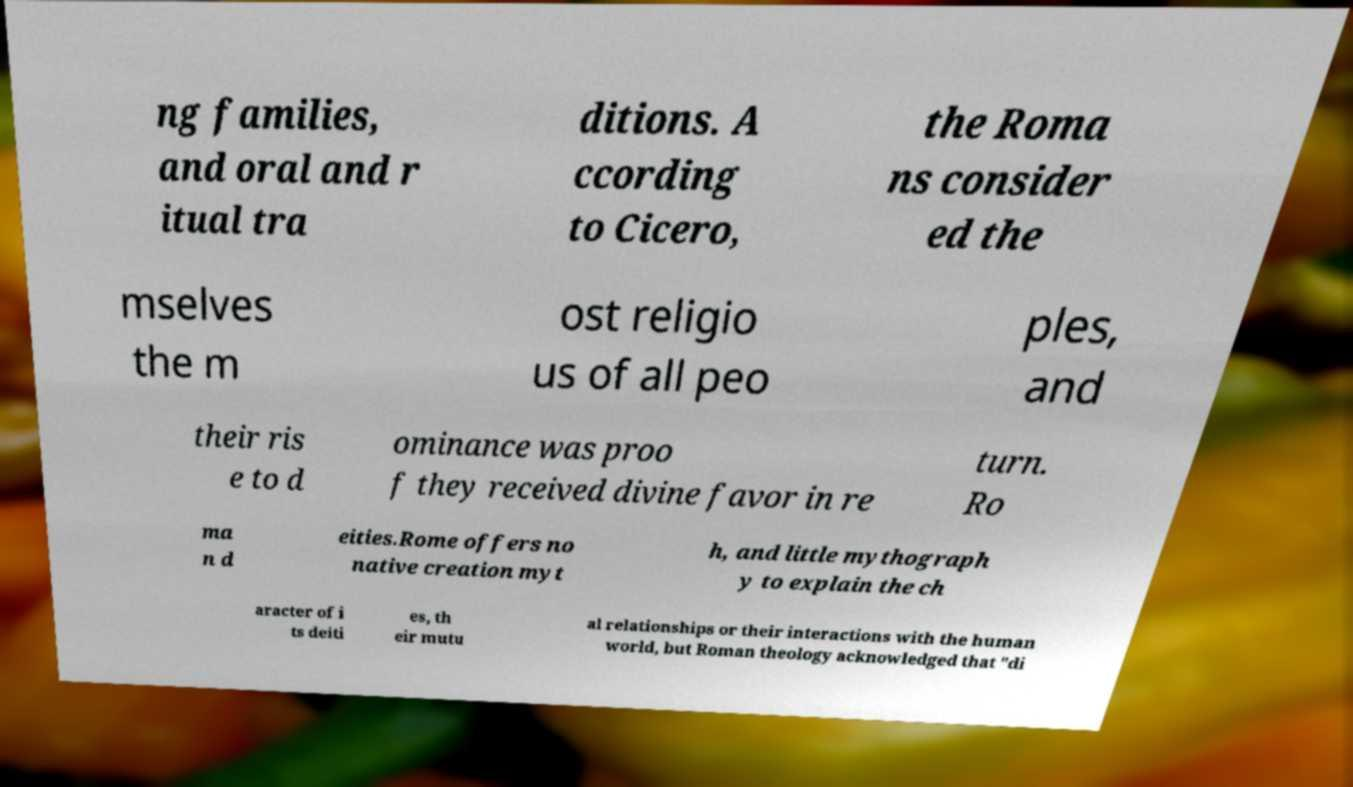Can you read and provide the text displayed in the image?This photo seems to have some interesting text. Can you extract and type it out for me? ng families, and oral and r itual tra ditions. A ccording to Cicero, the Roma ns consider ed the mselves the m ost religio us of all peo ples, and their ris e to d ominance was proo f they received divine favor in re turn. Ro ma n d eities.Rome offers no native creation myt h, and little mythograph y to explain the ch aracter of i ts deiti es, th eir mutu al relationships or their interactions with the human world, but Roman theology acknowledged that "di 